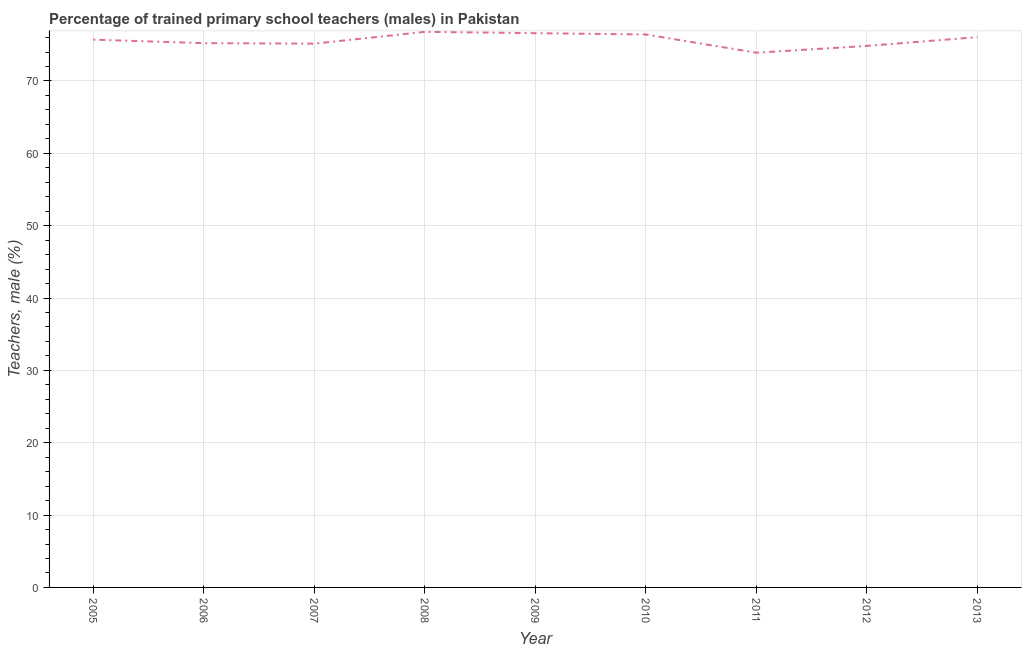What is the percentage of trained male teachers in 2012?
Offer a terse response. 74.85. Across all years, what is the maximum percentage of trained male teachers?
Give a very brief answer. 76.79. Across all years, what is the minimum percentage of trained male teachers?
Make the answer very short. 73.91. In which year was the percentage of trained male teachers minimum?
Your answer should be very brief. 2011. What is the sum of the percentage of trained male teachers?
Your answer should be compact. 680.73. What is the difference between the percentage of trained male teachers in 2005 and 2010?
Provide a short and direct response. -0.72. What is the average percentage of trained male teachers per year?
Your response must be concise. 75.64. What is the median percentage of trained male teachers?
Offer a terse response. 75.71. What is the ratio of the percentage of trained male teachers in 2009 to that in 2010?
Your answer should be very brief. 1. Is the percentage of trained male teachers in 2009 less than that in 2012?
Give a very brief answer. No. What is the difference between the highest and the second highest percentage of trained male teachers?
Offer a terse response. 0.18. What is the difference between the highest and the lowest percentage of trained male teachers?
Your answer should be compact. 2.88. In how many years, is the percentage of trained male teachers greater than the average percentage of trained male teachers taken over all years?
Give a very brief answer. 5. How many lines are there?
Make the answer very short. 1. How many years are there in the graph?
Offer a very short reply. 9. Are the values on the major ticks of Y-axis written in scientific E-notation?
Make the answer very short. No. Does the graph contain grids?
Make the answer very short. Yes. What is the title of the graph?
Ensure brevity in your answer.  Percentage of trained primary school teachers (males) in Pakistan. What is the label or title of the X-axis?
Your response must be concise. Year. What is the label or title of the Y-axis?
Make the answer very short. Teachers, male (%). What is the Teachers, male (%) in 2005?
Give a very brief answer. 75.71. What is the Teachers, male (%) in 2006?
Offer a very short reply. 75.23. What is the Teachers, male (%) in 2007?
Make the answer very short. 75.16. What is the Teachers, male (%) of 2008?
Keep it short and to the point. 76.79. What is the Teachers, male (%) in 2009?
Provide a succinct answer. 76.61. What is the Teachers, male (%) in 2010?
Provide a succinct answer. 76.43. What is the Teachers, male (%) in 2011?
Offer a very short reply. 73.91. What is the Teachers, male (%) in 2012?
Make the answer very short. 74.85. What is the Teachers, male (%) of 2013?
Offer a terse response. 76.06. What is the difference between the Teachers, male (%) in 2005 and 2006?
Offer a very short reply. 0.49. What is the difference between the Teachers, male (%) in 2005 and 2007?
Your response must be concise. 0.55. What is the difference between the Teachers, male (%) in 2005 and 2008?
Give a very brief answer. -1.07. What is the difference between the Teachers, male (%) in 2005 and 2009?
Provide a short and direct response. -0.89. What is the difference between the Teachers, male (%) in 2005 and 2010?
Your response must be concise. -0.72. What is the difference between the Teachers, male (%) in 2005 and 2011?
Your response must be concise. 1.81. What is the difference between the Teachers, male (%) in 2005 and 2012?
Keep it short and to the point. 0.87. What is the difference between the Teachers, male (%) in 2005 and 2013?
Provide a succinct answer. -0.35. What is the difference between the Teachers, male (%) in 2006 and 2007?
Your response must be concise. 0.07. What is the difference between the Teachers, male (%) in 2006 and 2008?
Offer a terse response. -1.56. What is the difference between the Teachers, male (%) in 2006 and 2009?
Give a very brief answer. -1.38. What is the difference between the Teachers, male (%) in 2006 and 2010?
Your response must be concise. -1.2. What is the difference between the Teachers, male (%) in 2006 and 2011?
Keep it short and to the point. 1.32. What is the difference between the Teachers, male (%) in 2006 and 2012?
Give a very brief answer. 0.38. What is the difference between the Teachers, male (%) in 2006 and 2013?
Make the answer very short. -0.83. What is the difference between the Teachers, male (%) in 2007 and 2008?
Offer a very short reply. -1.63. What is the difference between the Teachers, male (%) in 2007 and 2009?
Provide a succinct answer. -1.45. What is the difference between the Teachers, male (%) in 2007 and 2010?
Provide a succinct answer. -1.27. What is the difference between the Teachers, male (%) in 2007 and 2011?
Offer a very short reply. 1.25. What is the difference between the Teachers, male (%) in 2007 and 2012?
Ensure brevity in your answer.  0.31. What is the difference between the Teachers, male (%) in 2007 and 2013?
Provide a succinct answer. -0.9. What is the difference between the Teachers, male (%) in 2008 and 2009?
Offer a terse response. 0.18. What is the difference between the Teachers, male (%) in 2008 and 2010?
Offer a terse response. 0.36. What is the difference between the Teachers, male (%) in 2008 and 2011?
Keep it short and to the point. 2.88. What is the difference between the Teachers, male (%) in 2008 and 2012?
Offer a very short reply. 1.94. What is the difference between the Teachers, male (%) in 2008 and 2013?
Your response must be concise. 0.73. What is the difference between the Teachers, male (%) in 2009 and 2010?
Keep it short and to the point. 0.18. What is the difference between the Teachers, male (%) in 2009 and 2011?
Offer a very short reply. 2.7. What is the difference between the Teachers, male (%) in 2009 and 2012?
Offer a terse response. 1.76. What is the difference between the Teachers, male (%) in 2009 and 2013?
Keep it short and to the point. 0.55. What is the difference between the Teachers, male (%) in 2010 and 2011?
Your response must be concise. 2.52. What is the difference between the Teachers, male (%) in 2010 and 2012?
Ensure brevity in your answer.  1.58. What is the difference between the Teachers, male (%) in 2010 and 2013?
Keep it short and to the point. 0.37. What is the difference between the Teachers, male (%) in 2011 and 2012?
Ensure brevity in your answer.  -0.94. What is the difference between the Teachers, male (%) in 2011 and 2013?
Your answer should be compact. -2.15. What is the difference between the Teachers, male (%) in 2012 and 2013?
Your answer should be compact. -1.21. What is the ratio of the Teachers, male (%) in 2005 to that in 2007?
Ensure brevity in your answer.  1.01. What is the ratio of the Teachers, male (%) in 2005 to that in 2010?
Your answer should be compact. 0.99. What is the ratio of the Teachers, male (%) in 2006 to that in 2008?
Your answer should be very brief. 0.98. What is the ratio of the Teachers, male (%) in 2006 to that in 2010?
Your answer should be compact. 0.98. What is the ratio of the Teachers, male (%) in 2006 to that in 2013?
Provide a short and direct response. 0.99. What is the ratio of the Teachers, male (%) in 2007 to that in 2010?
Give a very brief answer. 0.98. What is the ratio of the Teachers, male (%) in 2007 to that in 2011?
Ensure brevity in your answer.  1.02. What is the ratio of the Teachers, male (%) in 2007 to that in 2012?
Your answer should be compact. 1. What is the ratio of the Teachers, male (%) in 2007 to that in 2013?
Give a very brief answer. 0.99. What is the ratio of the Teachers, male (%) in 2008 to that in 2011?
Provide a short and direct response. 1.04. What is the ratio of the Teachers, male (%) in 2008 to that in 2013?
Offer a very short reply. 1.01. What is the ratio of the Teachers, male (%) in 2009 to that in 2012?
Make the answer very short. 1.02. What is the ratio of the Teachers, male (%) in 2009 to that in 2013?
Offer a terse response. 1.01. What is the ratio of the Teachers, male (%) in 2010 to that in 2011?
Keep it short and to the point. 1.03. What is the ratio of the Teachers, male (%) in 2011 to that in 2013?
Give a very brief answer. 0.97. 